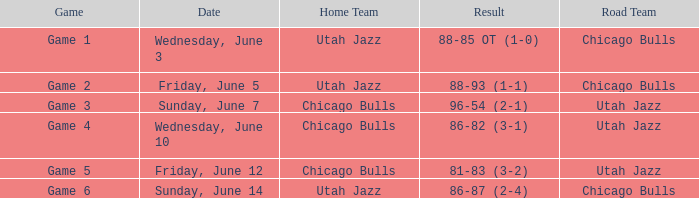Result of 86-87 (2-4) involves what home team? Utah Jazz. 